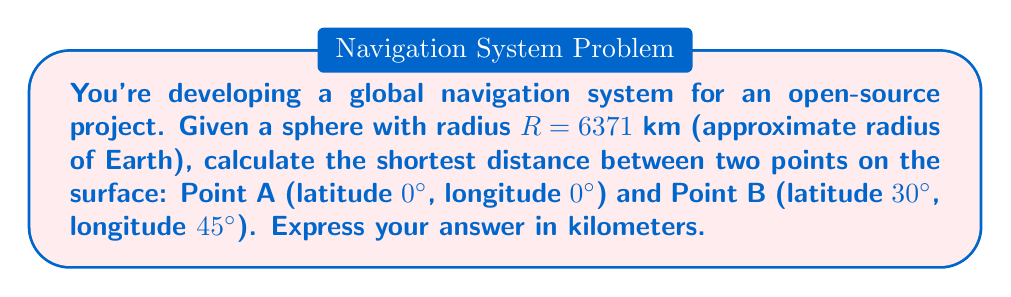Show me your answer to this math problem. To solve this problem, we'll use the great-circle distance formula, which gives the shortest path between two points on a spherical surface. This is relevant to non-Euclidean geometry as it deals with curved surfaces.

Step 1: Convert the coordinates to radians.
Latitude A: $\phi_1 = 0° = 0$ rad
Longitude A: $\lambda_1 = 0° = 0$ rad
Latitude B: $\phi_2 = 30° = \frac{\pi}{6}$ rad
Longitude B: $\lambda_2 = 45° = \frac{\pi}{4}$ rad

Step 2: Calculate the central angle $\Delta\sigma$ using the Haversine formula:

$$\Delta\sigma = 2 \arcsin\left(\sqrt{\sin^2\left(\frac{\phi_2 - \phi_1}{2}\right) + \cos(\phi_1)\cos(\phi_2)\sin^2\left(\frac{\lambda_2 - \lambda_1}{2}\right)}\right)$$

Substituting the values:

$$\Delta\sigma = 2 \arcsin\left(\sqrt{\sin^2\left(\frac{\pi/6 - 0}{2}\right) + \cos(0)\cos(\pi/6)\sin^2\left(\frac{\pi/4 - 0}{2}\right)}\right)$$

$$\Delta\sigma = 2 \arcsin\left(\sqrt{\sin^2\left(\frac{\pi}{12}\right) + \frac{\sqrt{3}}{2}\sin^2\left(\frac{\pi}{8}\right)}\right)$$

Step 3: Calculate the result of the Haversine formula:

$$\Delta\sigma \approx 0.8419$ rad$

Step 4: Calculate the great-circle distance $d$ using the formula:

$$d = R \cdot \Delta\sigma$$

Substituting the values:

$$d = 6371 \cdot 0.8419 \approx 5362.9$ km$$

Therefore, the shortest distance between the two points on the spherical surface is approximately 5362.9 km.
Answer: 5362.9 km 